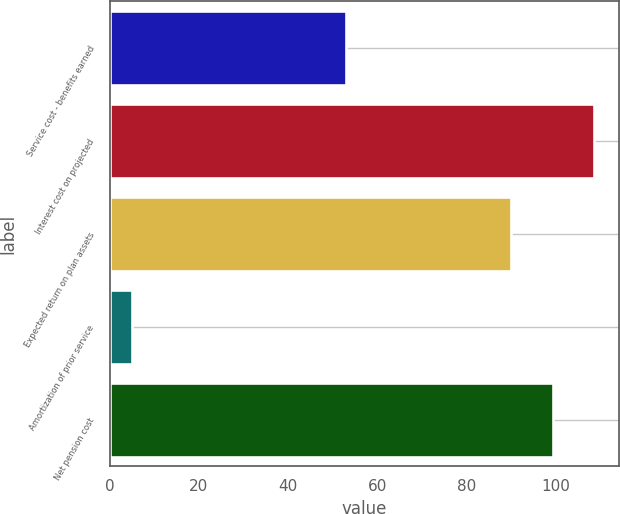Convert chart. <chart><loc_0><loc_0><loc_500><loc_500><bar_chart><fcel>Service cost - benefits earned<fcel>Interest cost on projected<fcel>Expected return on plan assets<fcel>Amortization of prior service<fcel>Net pension cost<nl><fcel>53<fcel>108.6<fcel>90<fcel>5<fcel>99.3<nl></chart> 